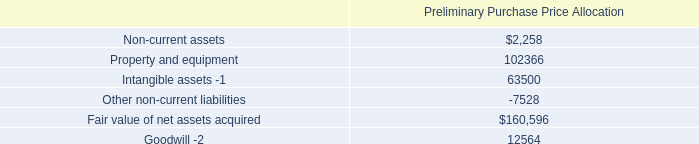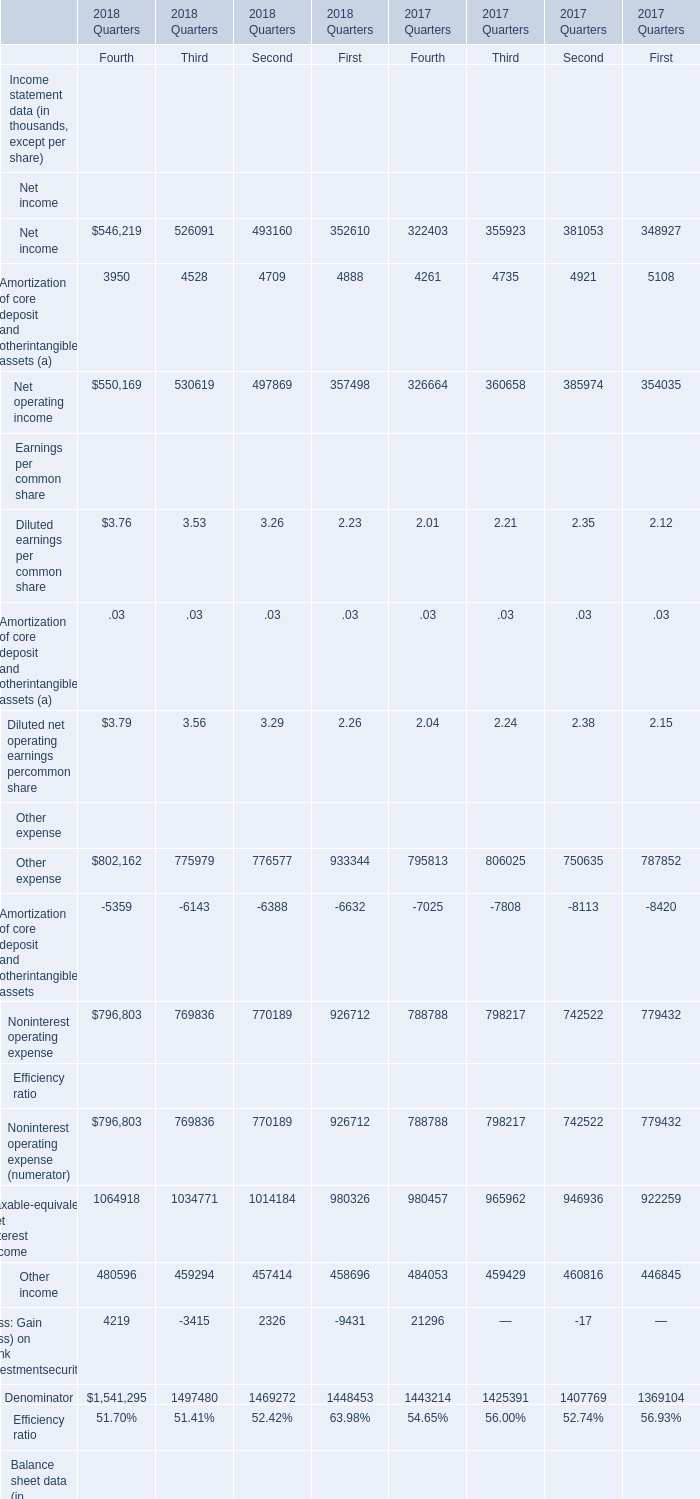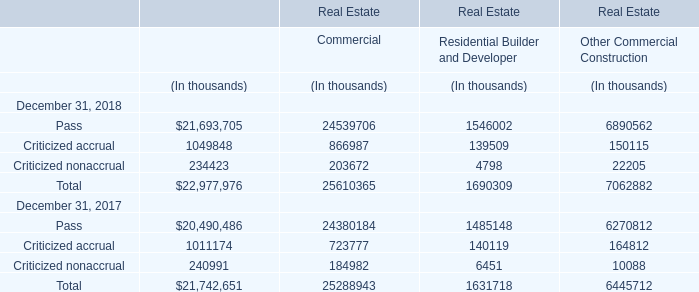What's the average of Goodwill Average common equity of 2018 Quarters First, and Property and equipment of Preliminary Purchase Price Allocation ? 
Computations: ((4593.0 + 102366.0) / 2)
Answer: 53479.5. 